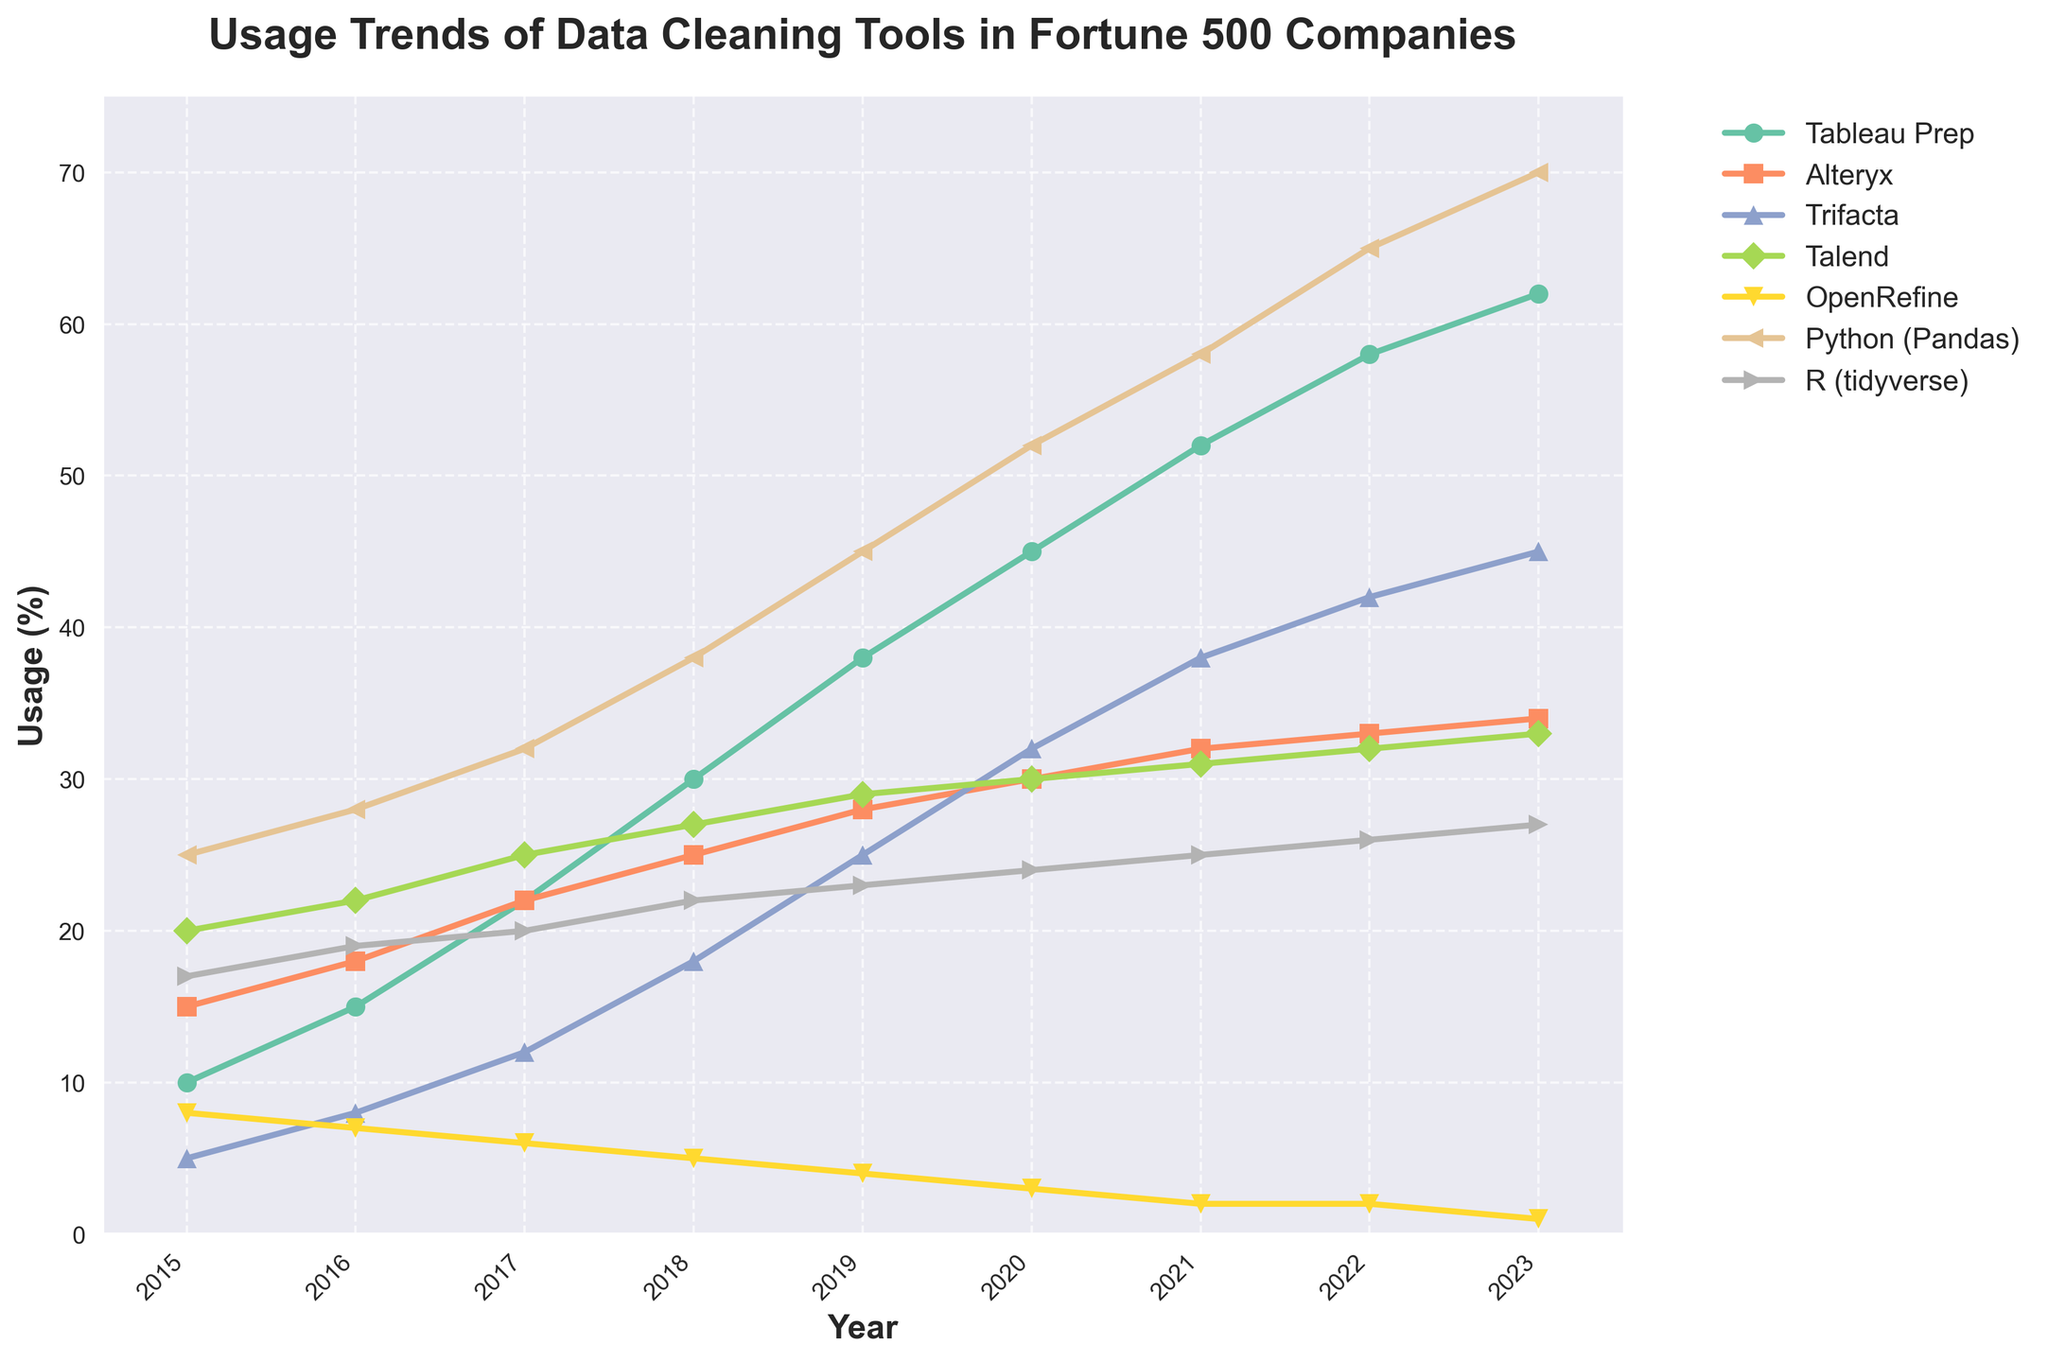What is the tool with the highest usage in 2023? By looking at the rightmost side of the plot for the year 2023, the tool with the highest value on the y-axis represents the highest usage. Python (Pandas) has the highest value reaching 70%.
Answer: Python (Pandas) Which tool had the greatest increase in usage from 2015 to 2023? To determine this, calculate the difference in usage for each tool between 2015 and 2023 then compare those differences. Python (Pandas) increased from 25% in 2015 to 70% in 2023, which is an increase of 45 percentage points, the highest among all tools.
Answer: Python (Pandas) Compare the usage trends of Tableau Prep and Alteryx between 2015 and 2023. For Tableau Prep, usage increases from 10% to 62% over the years, while Alteryx increases from 15% to 34%. Both trends show an upward pattern, but Tableau Prep's increase is more pronounced.
Answer: Tableau Prep had a steeper increase than Alteryx What is the average usage of Trifacta from 2015 to 2023? Sum the values of Trifacta from each year and then divide by the number of years: (5+8+12+18+25+32+38+42+45) / 9 = 225 / 9 = 25.
Answer: 25 Between which consecutive years did Talend see the smallest increase in usage? Compare the year-over-year usage changes for Talend: 2015-2016 (20 to 22, increase of 2), 2016-2017 (22 to 25, increase of 3), 2017-2018 (25 to 27, increase of 2), 2018-2019 (27 to 29, increase of 2), 2019-2020 (29 to 30, increase of 1), 2020-2021 (30 to 31, increase of 1), 2021-2022 (31 to 32, increase of 1), 2022-2023 (32 to 33, increase of 1). Talend saw the smallest increase (1) multiple times, but the earliest occurrence is between 2019 and 2020.
Answer: 2019-2020 In which year did OpenRefine usage drop below 5%, and was it consistent afterward? By examining the trend line for OpenRefine, we see the value drops below 5% in 2019 and continues to decrease consistently, reaching 1% by 2023.
Answer: 2019, Yes How many tools had higher usage than R (tidyverse) in 2023? By looking at the rightmost part of the plot for 2023, the y-values of the tools are compared. Tableau Prep (62%), Alteryx (34%), Trifacta (45%), Talend (33%), Python (Pandas) (70%) all have higher values than R (tidyverse) at 27%. Hence, 5 tools had higher usage.
Answer: 5 What is the combined usage of Tableau Prep and Python (Pandas) in 2020? Add the usage percentages of Tableau Prep and Python (Pandas) for the year 2020: 45% (Tableau Prep) + 52% (Python (Pandas)) = 97%.
Answer: 97 Which tool had a steady decline in usage over the years, and what might be the reason? OpenRefine shows a continuous decline in its usage from 2015 (8%) to 2023 (1%). One possible reason could be the rise and adoption of more advanced and integrated tools like Python (Pandas).
Answer: OpenRefine, Increasing adoption of advanced tools Is there any year when all tools show an increase compared to the previous year? Analyze the year-to-year trends for each tool. From 2019 to 2020, all tools (Tableau Prep, Alteryx, Trifacta, Talend, Python (Pandas), and R (tidyverse)) show an increase in usage. OpenRefine, however, decreases from 4% to 3%, so no such year exists.
Answer: No 